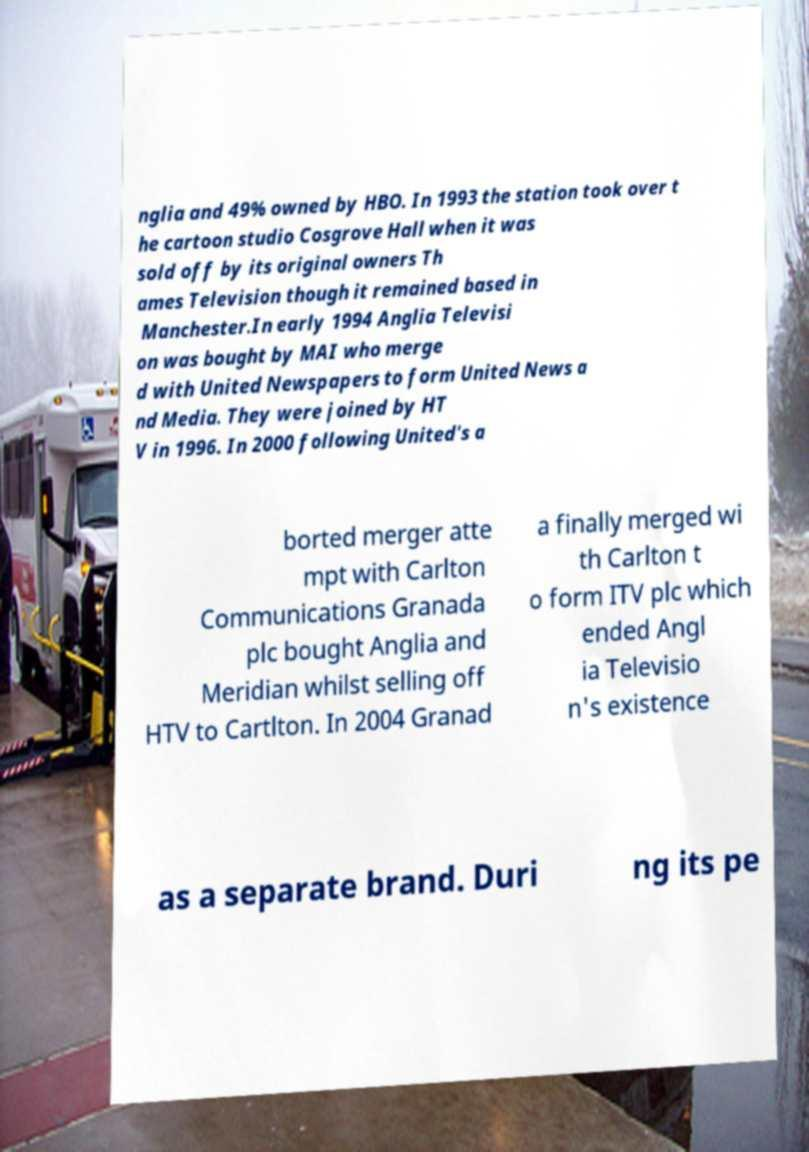I need the written content from this picture converted into text. Can you do that? nglia and 49% owned by HBO. In 1993 the station took over t he cartoon studio Cosgrove Hall when it was sold off by its original owners Th ames Television though it remained based in Manchester.In early 1994 Anglia Televisi on was bought by MAI who merge d with United Newspapers to form United News a nd Media. They were joined by HT V in 1996. In 2000 following United's a borted merger atte mpt with Carlton Communications Granada plc bought Anglia and Meridian whilst selling off HTV to Cartlton. In 2004 Granad a finally merged wi th Carlton t o form ITV plc which ended Angl ia Televisio n's existence as a separate brand. Duri ng its pe 